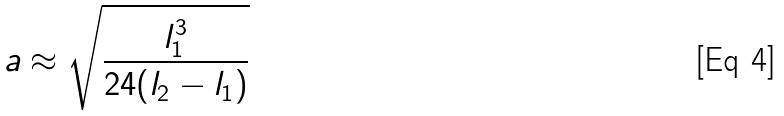<formula> <loc_0><loc_0><loc_500><loc_500>a \approx \sqrt { \frac { l _ { 1 } ^ { 3 } } { 2 4 ( l _ { 2 } - l _ { 1 } ) } }</formula> 